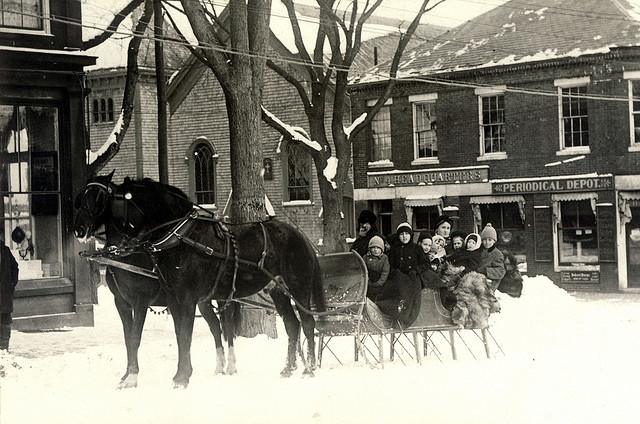Is this picture old or new?
Quick response, please. Old. What does the sign on the building say?
Write a very short answer. Periodical depot. What is pulling the sleigh?
Be succinct. Horses. 